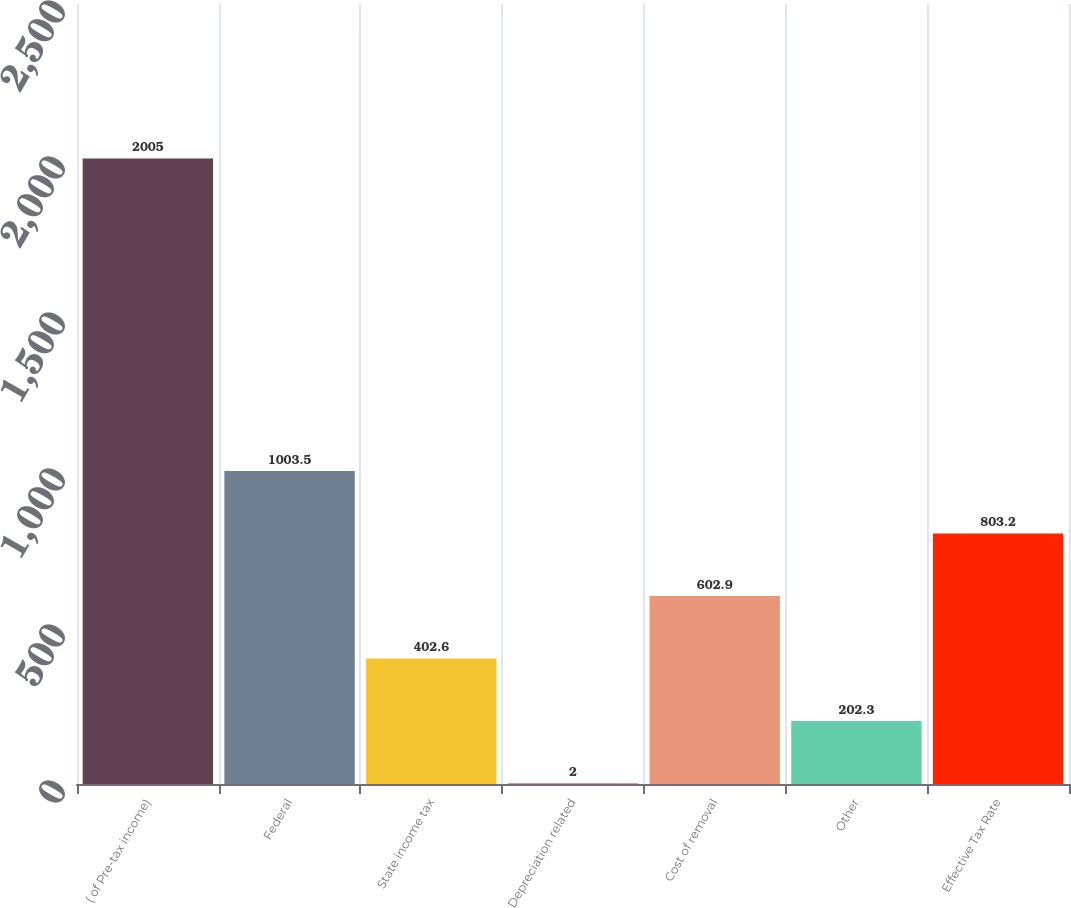Convert chart. <chart><loc_0><loc_0><loc_500><loc_500><bar_chart><fcel>( of Pre-tax income)<fcel>Federal<fcel>State income tax<fcel>Depreciation related<fcel>Cost of removal<fcel>Other<fcel>Effective Tax Rate<nl><fcel>2005<fcel>1003.5<fcel>402.6<fcel>2<fcel>602.9<fcel>202.3<fcel>803.2<nl></chart> 